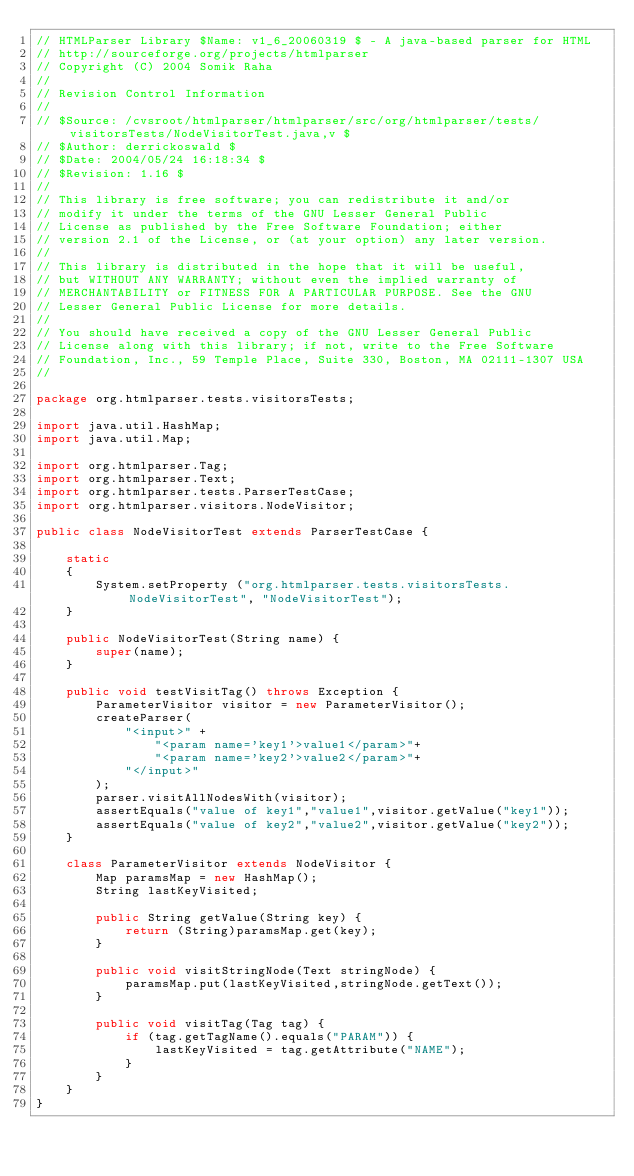Convert code to text. <code><loc_0><loc_0><loc_500><loc_500><_Java_>// HTMLParser Library $Name: v1_6_20060319 $ - A java-based parser for HTML
// http://sourceforge.org/projects/htmlparser
// Copyright (C) 2004 Somik Raha
//
// Revision Control Information
//
// $Source: /cvsroot/htmlparser/htmlparser/src/org/htmlparser/tests/visitorsTests/NodeVisitorTest.java,v $
// $Author: derrickoswald $
// $Date: 2004/05/24 16:18:34 $
// $Revision: 1.16 $
//
// This library is free software; you can redistribute it and/or
// modify it under the terms of the GNU Lesser General Public
// License as published by the Free Software Foundation; either
// version 2.1 of the License, or (at your option) any later version.
//
// This library is distributed in the hope that it will be useful,
// but WITHOUT ANY WARRANTY; without even the implied warranty of
// MERCHANTABILITY or FITNESS FOR A PARTICULAR PURPOSE. See the GNU
// Lesser General Public License for more details.
//
// You should have received a copy of the GNU Lesser General Public
// License along with this library; if not, write to the Free Software
// Foundation, Inc., 59 Temple Place, Suite 330, Boston, MA 02111-1307 USA
//

package org.htmlparser.tests.visitorsTests;

import java.util.HashMap;
import java.util.Map;

import org.htmlparser.Tag;
import org.htmlparser.Text;
import org.htmlparser.tests.ParserTestCase;
import org.htmlparser.visitors.NodeVisitor;

public class NodeVisitorTest extends ParserTestCase {

    static
    {
        System.setProperty ("org.htmlparser.tests.visitorsTests.NodeVisitorTest", "NodeVisitorTest");
    }

    public NodeVisitorTest(String name) {
        super(name);
    }

    public void testVisitTag() throws Exception {
        ParameterVisitor visitor = new ParameterVisitor();
        createParser(
            "<input>" +
                "<param name='key1'>value1</param>"+
                "<param name='key2'>value2</param>"+
            "</input>"
        );
        parser.visitAllNodesWith(visitor);
        assertEquals("value of key1","value1",visitor.getValue("key1"));
        assertEquals("value of key2","value2",visitor.getValue("key2"));
    }

    class ParameterVisitor extends NodeVisitor {
        Map paramsMap = new HashMap();
        String lastKeyVisited;

        public String getValue(String key) {
            return (String)paramsMap.get(key);
        }

        public void visitStringNode(Text stringNode) {
            paramsMap.put(lastKeyVisited,stringNode.getText());
        }

        public void visitTag(Tag tag) {
            if (tag.getTagName().equals("PARAM")) {
                lastKeyVisited = tag.getAttribute("NAME");
            }
        }
    }
}
</code> 